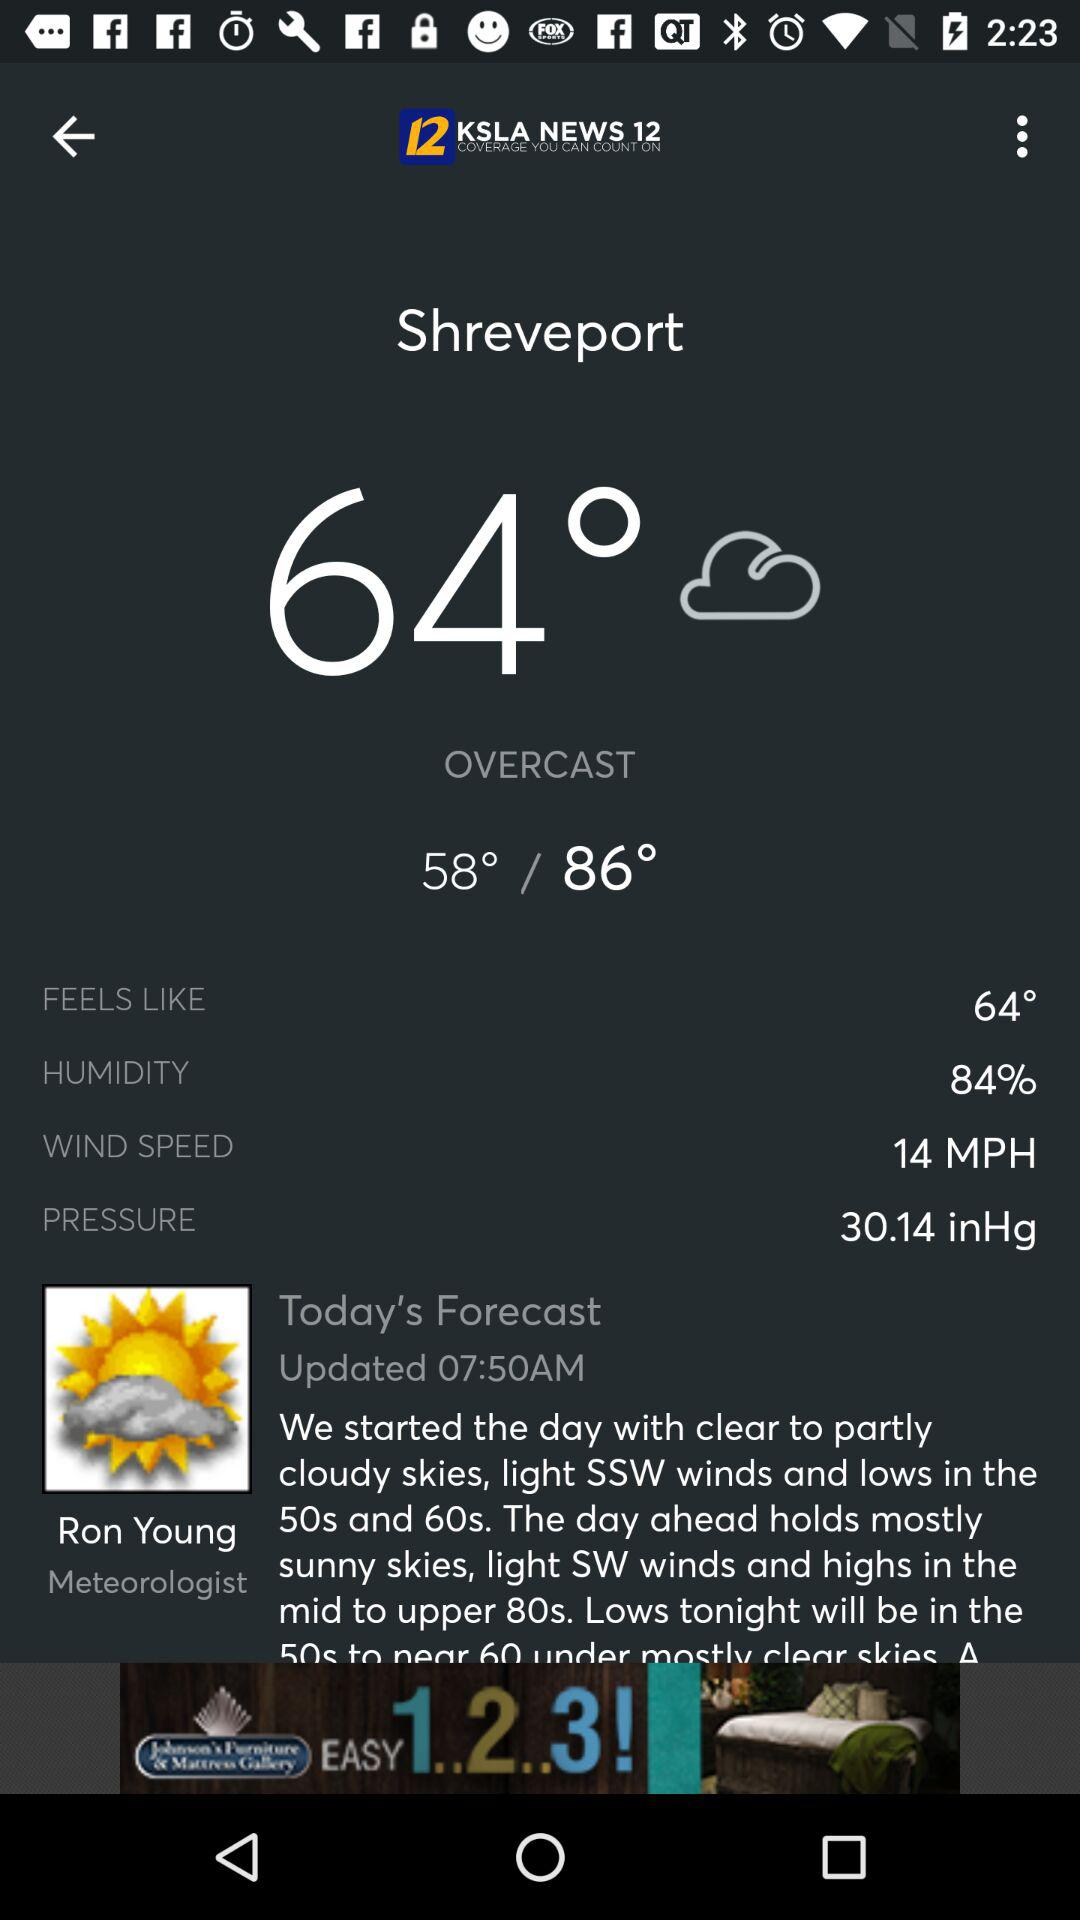What is the humidity percentage?
Answer the question using a single word or phrase. 84% 